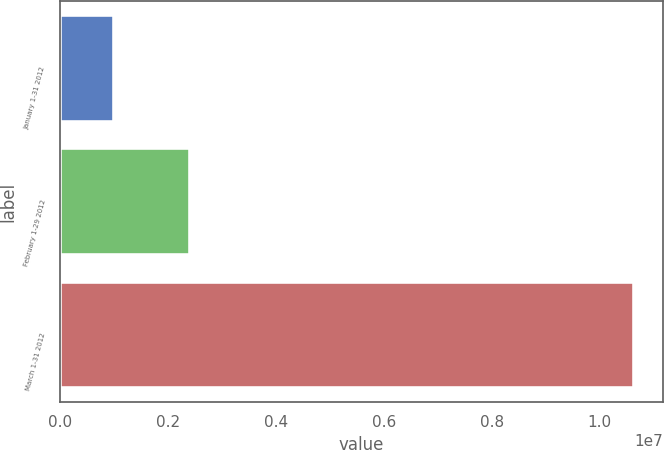Convert chart. <chart><loc_0><loc_0><loc_500><loc_500><bar_chart><fcel>January 1-31 2012<fcel>February 1-29 2012<fcel>March 1-31 2012<nl><fcel>1.0056e+06<fcel>2.4056e+06<fcel>1.06421e+07<nl></chart> 